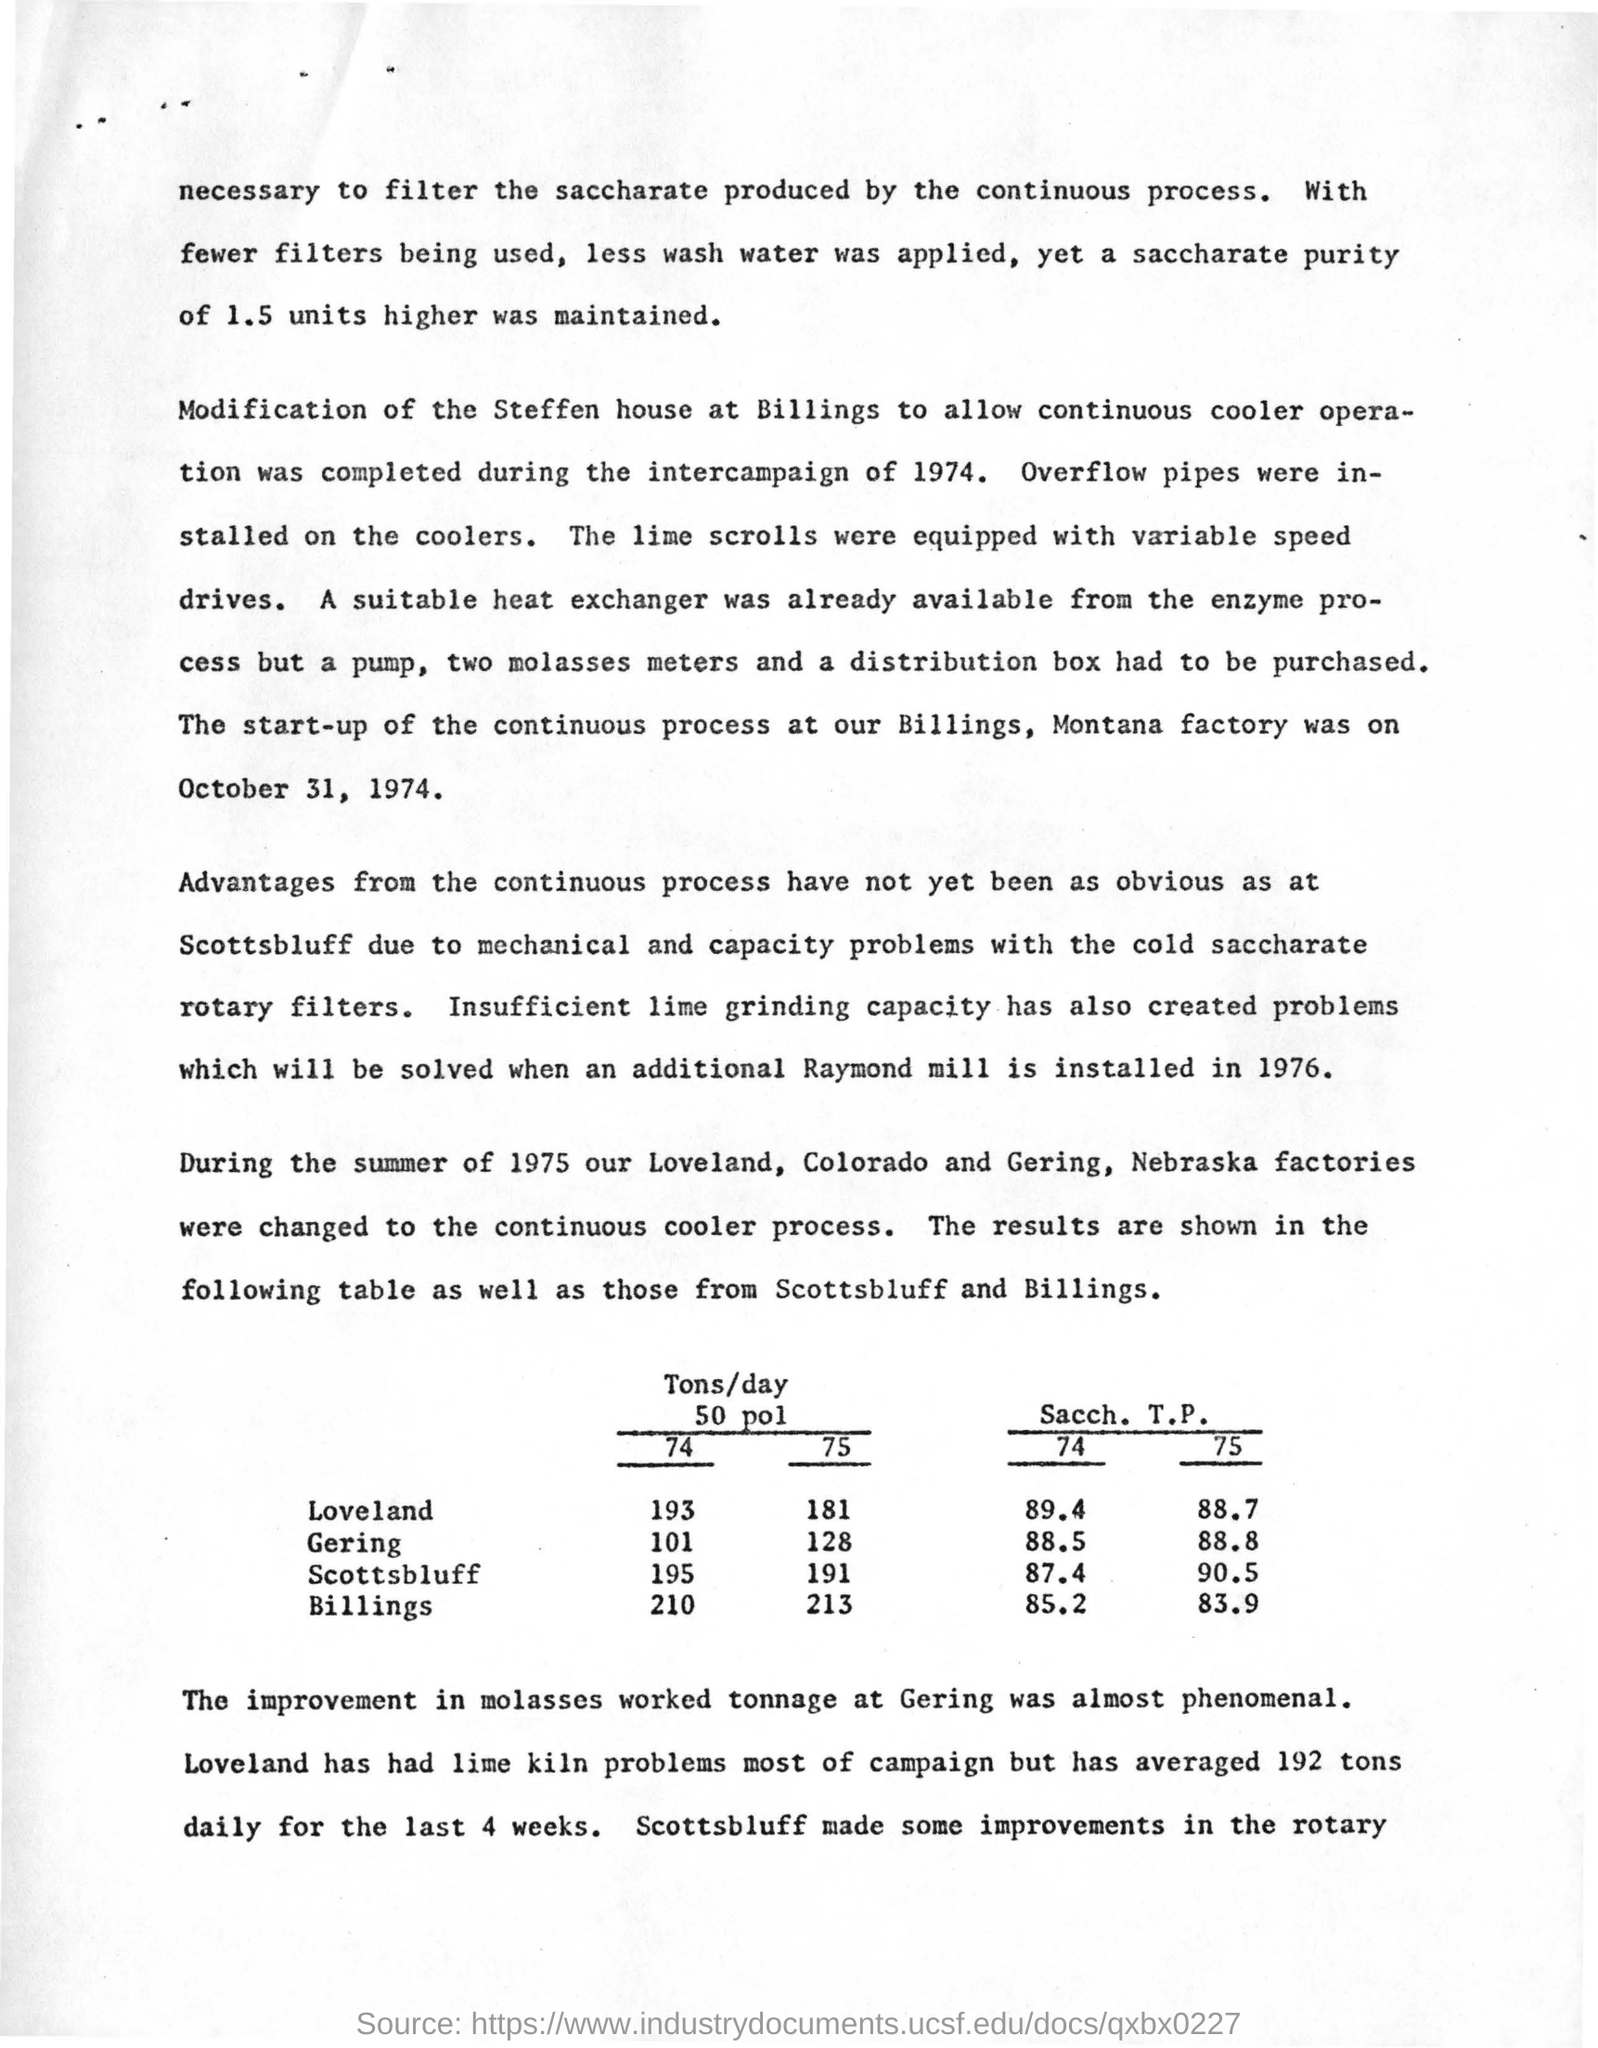When was the start-up of the continuous process at Billings,  Montana factory?
Keep it short and to the point. October 31, 1974. In which year, raymond mill is installed?
Keep it short and to the point. 1976. In summer of 1975 which factories  were changed to continuous cooler process?
Provide a succinct answer. Loveland, colorado and gering, nebraska factories. At gering  for 74 how many tons/day of  50 pol ?
Your response must be concise. 101. At Gering How was work tonnage improvement in molasses ?
Provide a short and direct response. Almost phenomenal. 